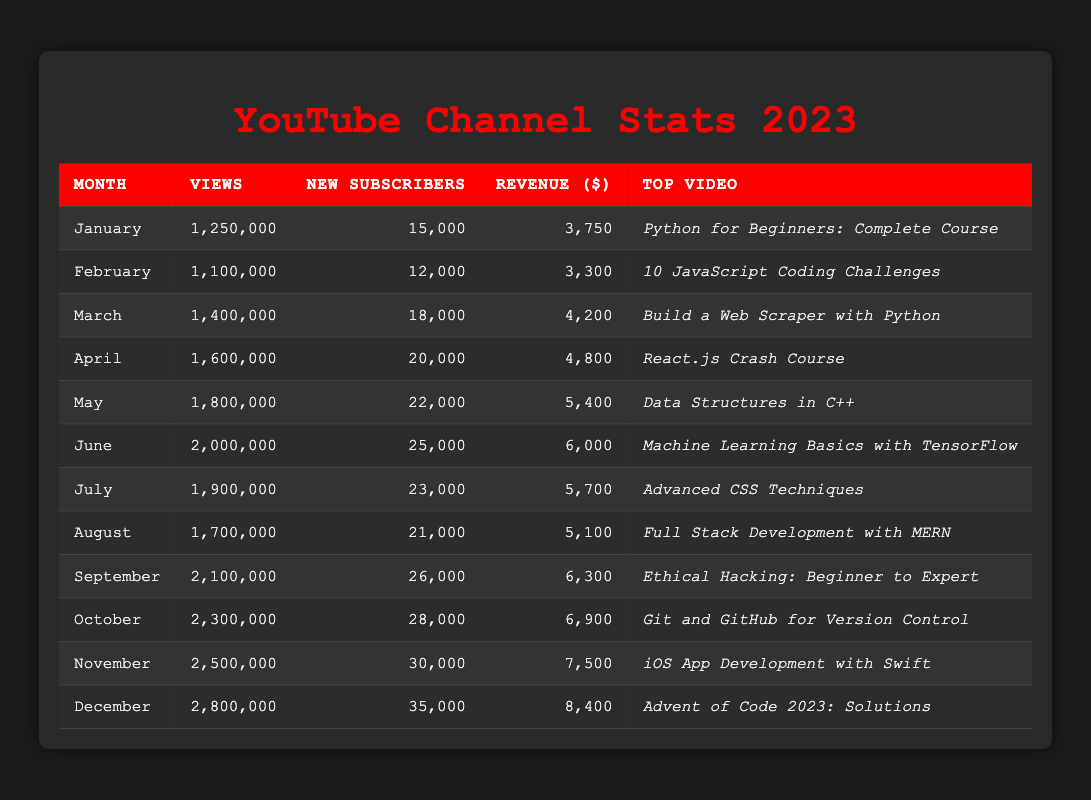What was the top video for December? According to the table, the top video for December is specified in the "Top Video" column for that month. For December, it is "Advent of Code 2023: Solutions."
Answer: Advent of Code 2023: Solutions In which month did the channel gain the highest number of new subscribers? To find this, we look at the "New Subscribers" column for each month, identifying the maximum value. In comparing the numbers, December has 35,000 new subscribers, which is the highest for the year.
Answer: December What was the total revenue generated from January to March? We sum the revenue values from the "Revenue ($)" column for January (3750), February (3300), and March (4200). Adding them together: 3750 + 3300 + 4200 = 11250 dollars.
Answer: 11250 Was the revenue generated in November higher than the average revenue from January to October? First, we calculate the total revenue from January to October by summing each month's revenue, which is 3750 + 3300 + 4200 + 4800 + 5400 + 6000 + 5700 + 5100 + 6300 + 6900 =  50550. Then, we divide by 10 to find the average: 50550 / 10 = 5055. Since November's revenue is 7500, which is higher than 5055, the answer is yes.
Answer: Yes What was the increase in views from January to June? We take the views from January (1,250,000) and subtract the views from June (2,000,000). Calculating 2,000,000 - 1,250,000 gives us an increase of 750,000 views from January to June.
Answer: 750000 How many views were accumulated from April to August? To find the total views from April to August, we add the views from those months together: April (1,600,000), May (1,800,000), June (2,000,000), July (1,900,000), and August (1,700,000). The sum is 1,600,000 + 1,800,000 + 2,000,000 + 1,900,000 + 1,700,000 = 9,000,000 views.
Answer: 9000000 What was the revenue for the video that attracted the most views in October? In October, the video "Git and GitHub for Version Control" generated $6,900 in revenue according to the "Revenue ($)" column for that month. Thus, the answer directly correlates to the data in that row.
Answer: 6900 Did the channel earn more revenue in August than in June? By comparing the revenue figures, August's revenue is 5,100, while June's is 6,000. Since 5,100 is less than 6,000, the answer is no.
Answer: No Which month had the smallest number of new subscribers? We look at the "New Subscribers" column and find the lowest number. In February, there were 12,000 new subscribers, which is lower than any other month.
Answer: February 